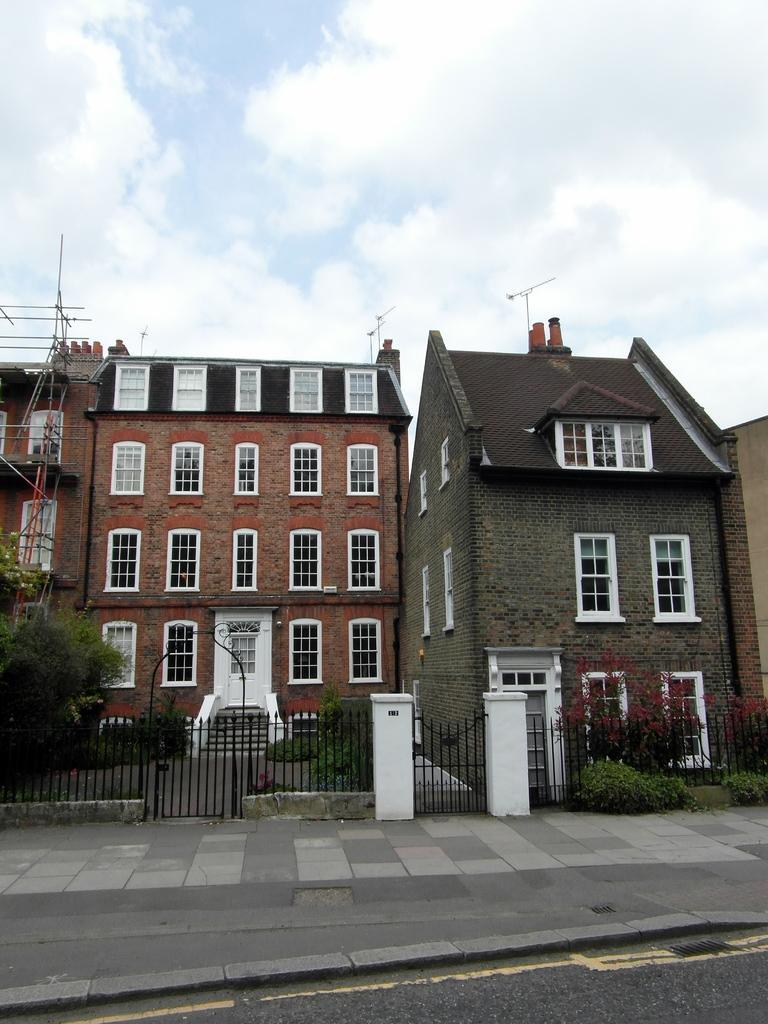Can you describe this image briefly? This picture is clicked outside. In the foreground we can see the pavement and the road. In the center there is a staircase and we can see the houses and the doors and windows of the houses and we can see the plants, fence and in the background there is a sky which is full of clouds. 